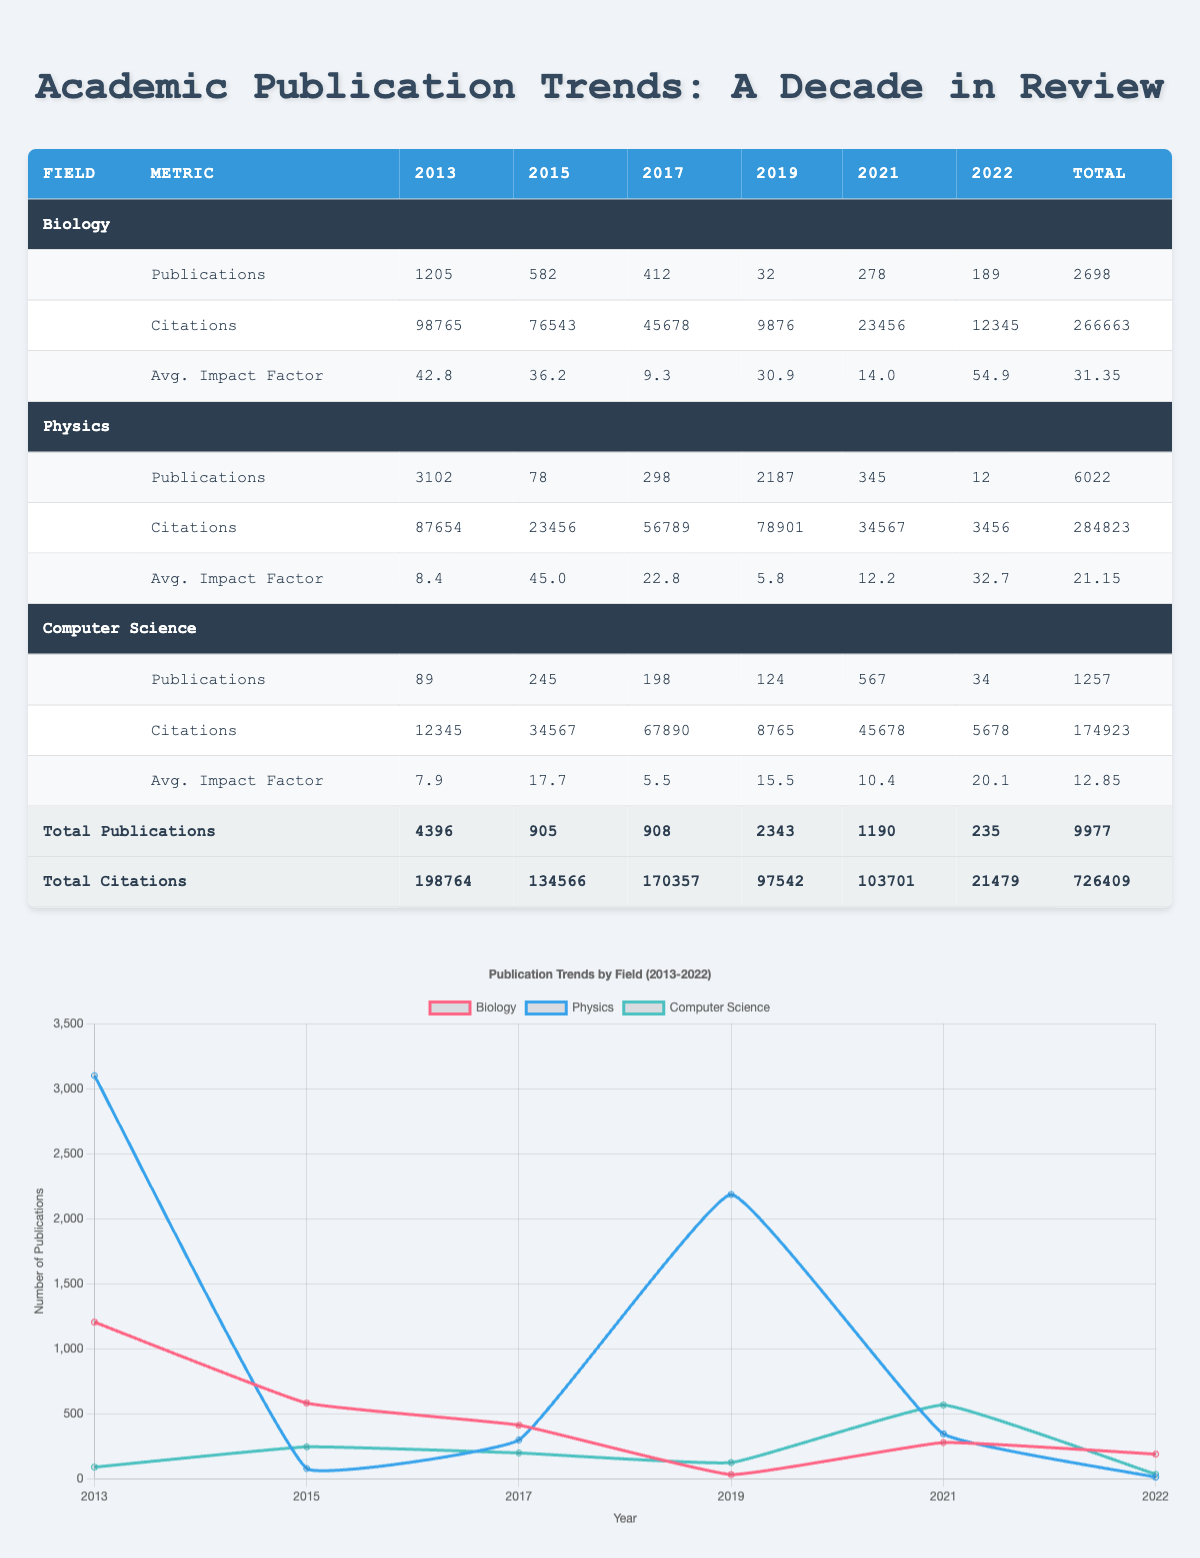What is the total number of publications in Biology from 2013 to 2022? To find the total number of publications in Biology, add the publications from each year: 1205 (2013) + 582 (2015) + 412 (2017) + 32 (2019) + 278 (2021) + 189 (2022) = 2698.
Answer: 2698 Which year had the highest number of publications in Physics? Looking at the years in the Physics row, 2013 has 3102 publications, which is higher than any other year listed (2015 - 78, 2017 - 298, 2019 - 2187, 2021 - 345, 2022 - 12). Therefore, 2013 had the highest publications.
Answer: 2013 What is the average impact factor for publications in Computer Science from 2013 to 2022? To find the average impact factor, add the values for Computer Science: 7.9 (2013) + 17.7 (2015) + 5.5 (2017) + 15.5 (2019) + 10.4 (2021) + 20.1 (2022) = 77.1. There are 6 data points, thus the average is 77.1 / 6 = 12.85.
Answer: 12.85 Did the total number of citations for Biology exceed the total citations for Physics? The total citations for Biology is 266663 and for Physics, it is 284823. Since 266663 < 284823, the statement is false.
Answer: No How many more citations did Physics receive in 2013 than in 2015? In 2013, Physics received 87654 citations and in 2015 it received 23456 citations. To determine the difference, subtract: 87654 - 23456 = 64198.
Answer: 64198 Which field overall had the lowest number of publications in 2022? Looking at the 2022 data: Biology has 189, Physics has 12, and Computer Science has 34 publications. Physics has the least publications out of these three.
Answer: Physics What is the total number of publications across all fields for the years 2019 and 2021? For 2019: Biology - 32, Physics - 2187, Computer Science - 124. Sum for 2019 is 32 + 2187 + 124 = 2343. For 2021: Biology - 278, Physics - 345, Computer Science - 567. Sum for 2021 is 278 + 345 + 567 = 1190. Finally, total publications for both years is 2343 + 1190 = 3533.
Answer: 3533 Was there an increase in the average impact factor of Biology from 2015 to 2022? The average impact factor for Biology in 2015 is 36.2 and in 2022 is 54.9. Since 54.9 > 36.2, there was an increase.
Answer: Yes How many citations did Computer Science journals receive in total from 2013 to 2022? Summing up the citations for Computer Science: 12345 (2013) + 34567 (2015) + 67890 (2017) + 8765 (2019) + 45678 (2021) + 5678 (2022) = 174923.
Answer: 174923 